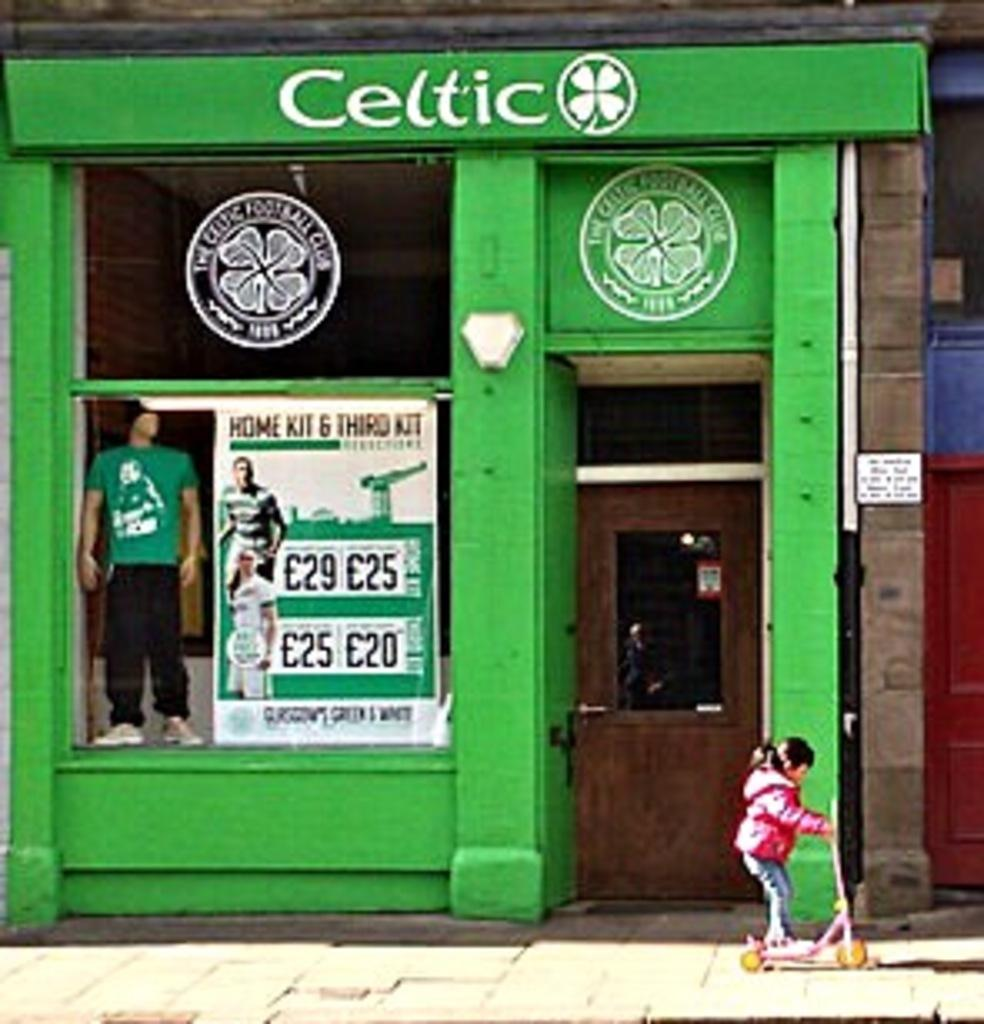<image>
Render a clear and concise summary of the photo. A green storefront with the word celtic on the top. 